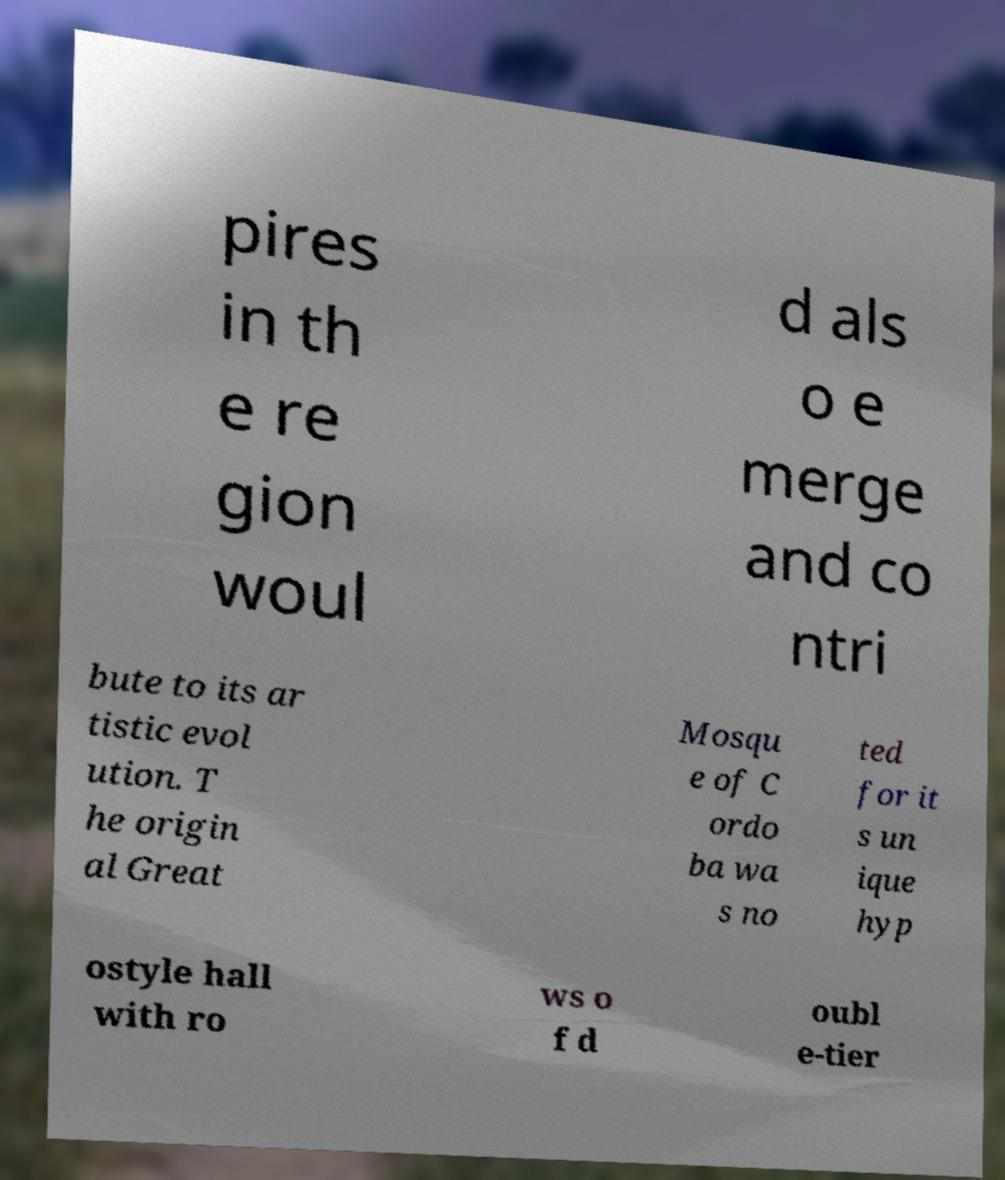Please identify and transcribe the text found in this image. pires in th e re gion woul d als o e merge and co ntri bute to its ar tistic evol ution. T he origin al Great Mosqu e of C ordo ba wa s no ted for it s un ique hyp ostyle hall with ro ws o f d oubl e-tier 